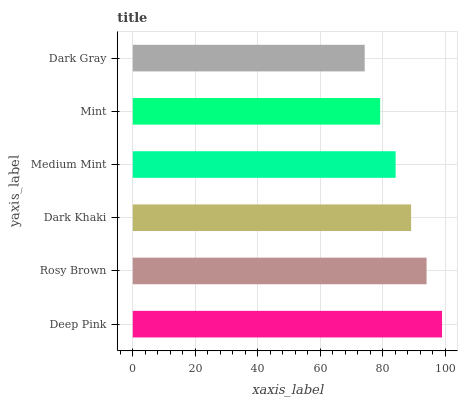Is Dark Gray the minimum?
Answer yes or no. Yes. Is Deep Pink the maximum?
Answer yes or no. Yes. Is Rosy Brown the minimum?
Answer yes or no. No. Is Rosy Brown the maximum?
Answer yes or no. No. Is Deep Pink greater than Rosy Brown?
Answer yes or no. Yes. Is Rosy Brown less than Deep Pink?
Answer yes or no. Yes. Is Rosy Brown greater than Deep Pink?
Answer yes or no. No. Is Deep Pink less than Rosy Brown?
Answer yes or no. No. Is Dark Khaki the high median?
Answer yes or no. Yes. Is Medium Mint the low median?
Answer yes or no. Yes. Is Dark Gray the high median?
Answer yes or no. No. Is Mint the low median?
Answer yes or no. No. 